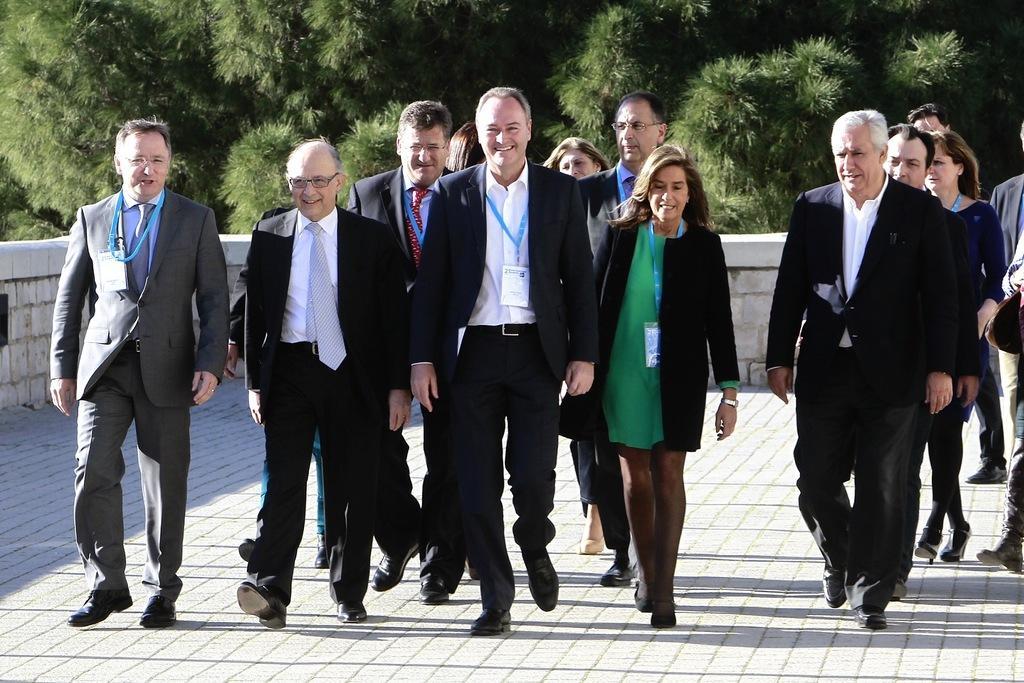Can you describe this image briefly? In the center of the image there are people walking on the road. In the background of the image there are trees. 